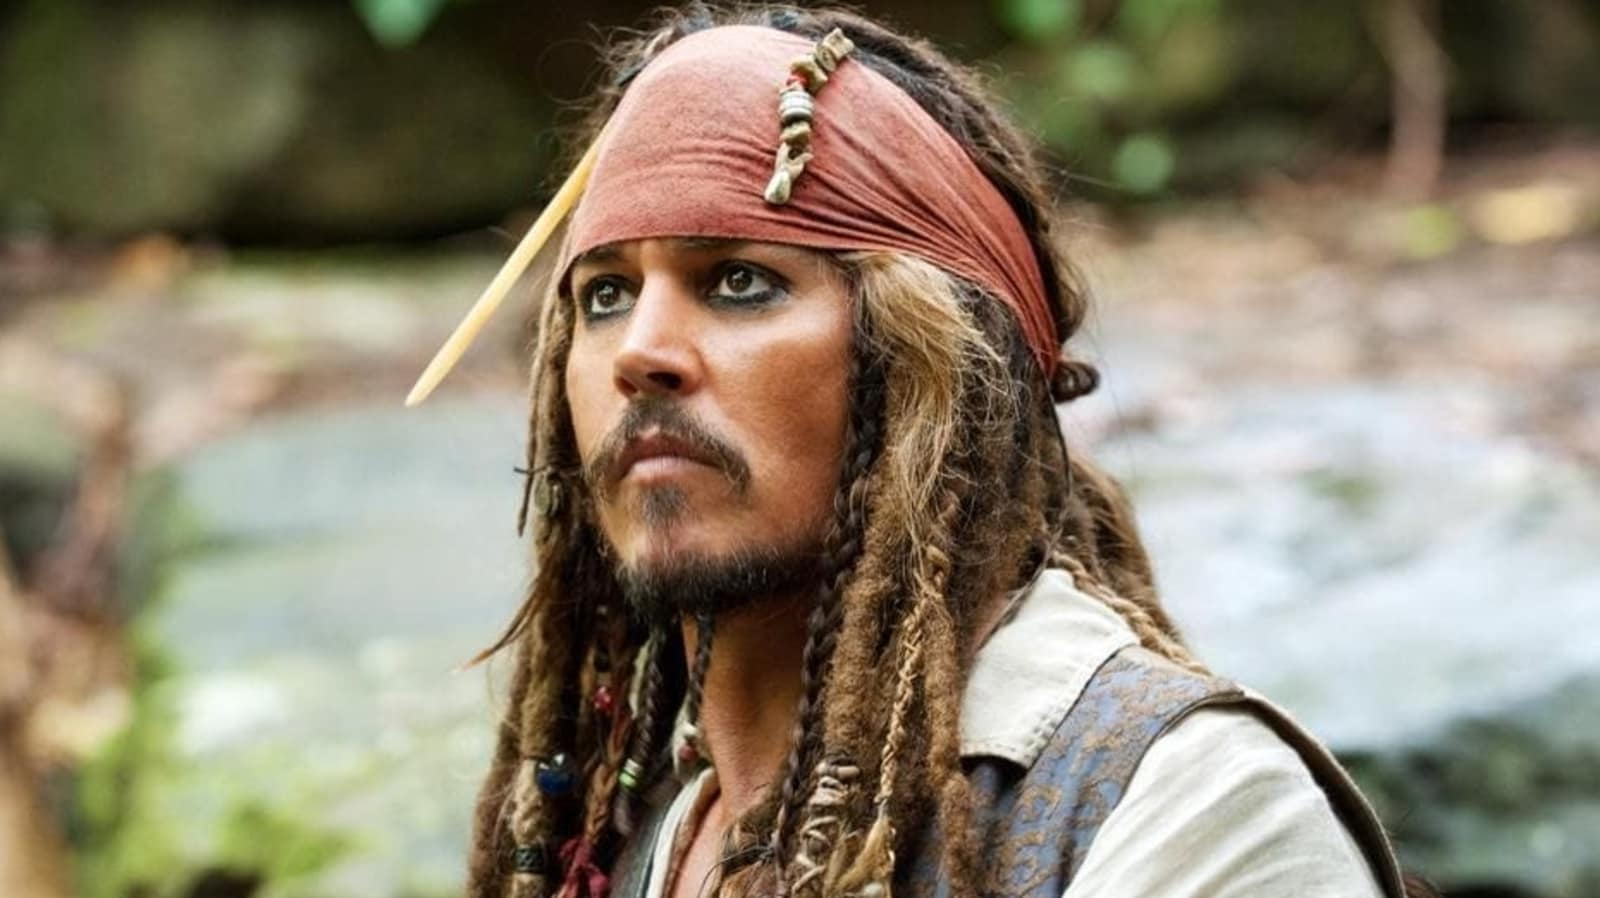Analyze the image in a comprehensive and detailed manner. In the image, we see a character who bears a striking resemblance to Johnny Depp, notably in his iconic portrayal as Captain Jack Sparrow from the Pirates of the Caribbean film series. He is depicted standing in a forest, with a serene stream and a blurred but green and lush background that suggests a tranquil setting. His attire is quintessentially pirate-like: a red bandana adorned with a feather, a white shirt, and a brown vest. His hair is styled into long dreadlocks, and he has a goatee, capturing the rugged charm of his character. His gaze is directed slightly off to the side, and he wears a serious expression, which could indicate contemplation or anticipation of impending adventure or danger. 